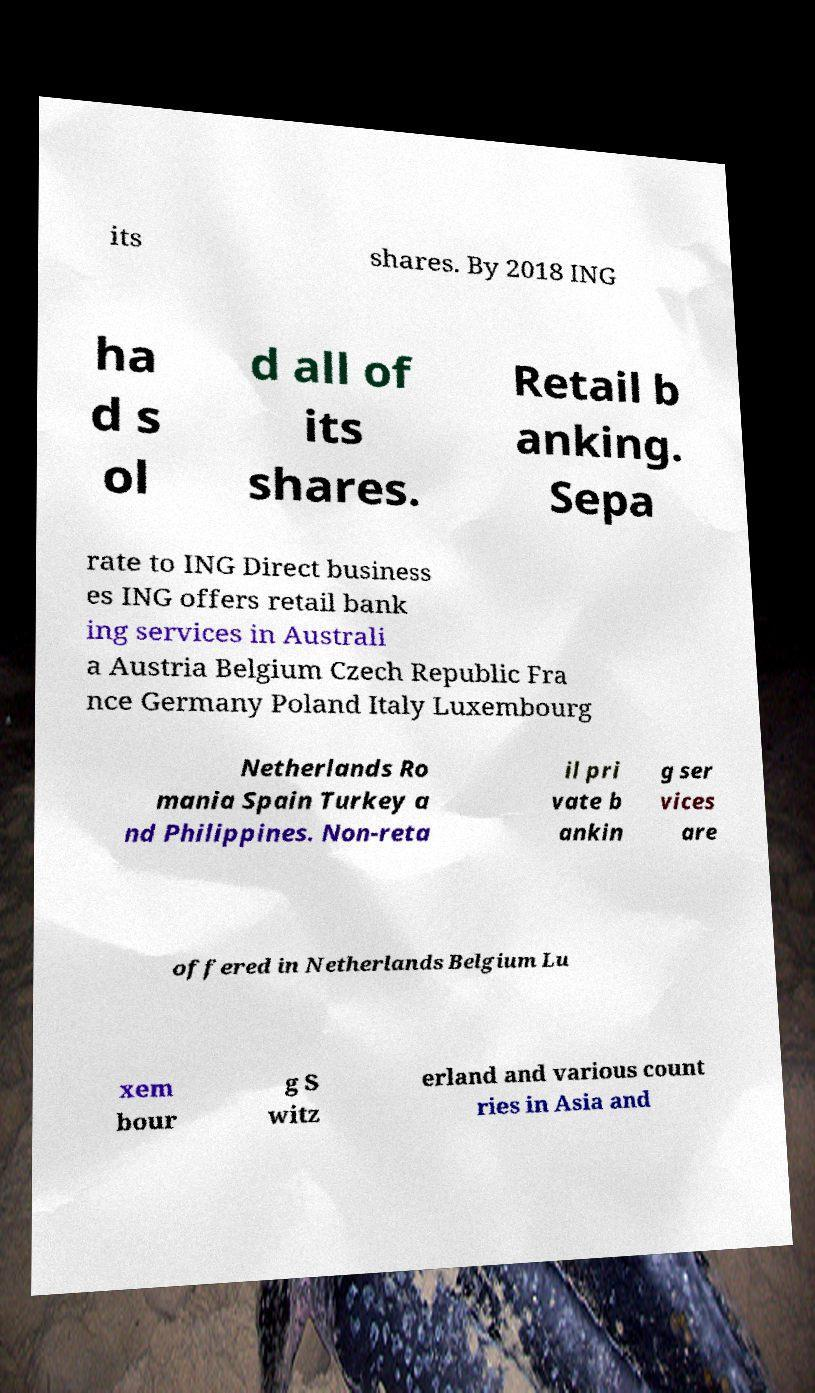Can you read and provide the text displayed in the image?This photo seems to have some interesting text. Can you extract and type it out for me? its shares. By 2018 ING ha d s ol d all of its shares. Retail b anking. Sepa rate to ING Direct business es ING offers retail bank ing services in Australi a Austria Belgium Czech Republic Fra nce Germany Poland Italy Luxembourg Netherlands Ro mania Spain Turkey a nd Philippines. Non-reta il pri vate b ankin g ser vices are offered in Netherlands Belgium Lu xem bour g S witz erland and various count ries in Asia and 